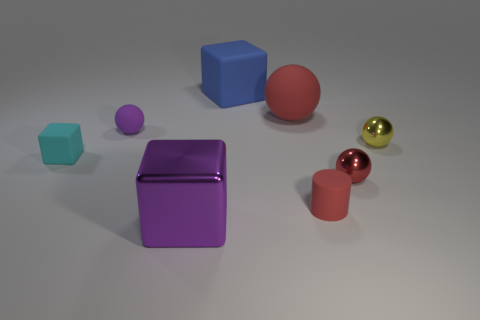Subtract all red balls. How many were subtracted if there are1red balls left? 1 Subtract all purple metal blocks. How many blocks are left? 2 Subtract all blocks. How many objects are left? 5 Subtract 3 balls. How many balls are left? 1 Subtract all purple balls. How many balls are left? 3 Add 1 tiny metal things. How many objects exist? 9 Add 3 small yellow objects. How many small yellow objects exist? 4 Subtract 1 red cylinders. How many objects are left? 7 Subtract all brown cylinders. Subtract all gray cubes. How many cylinders are left? 1 Subtract all brown cylinders. How many cyan cubes are left? 1 